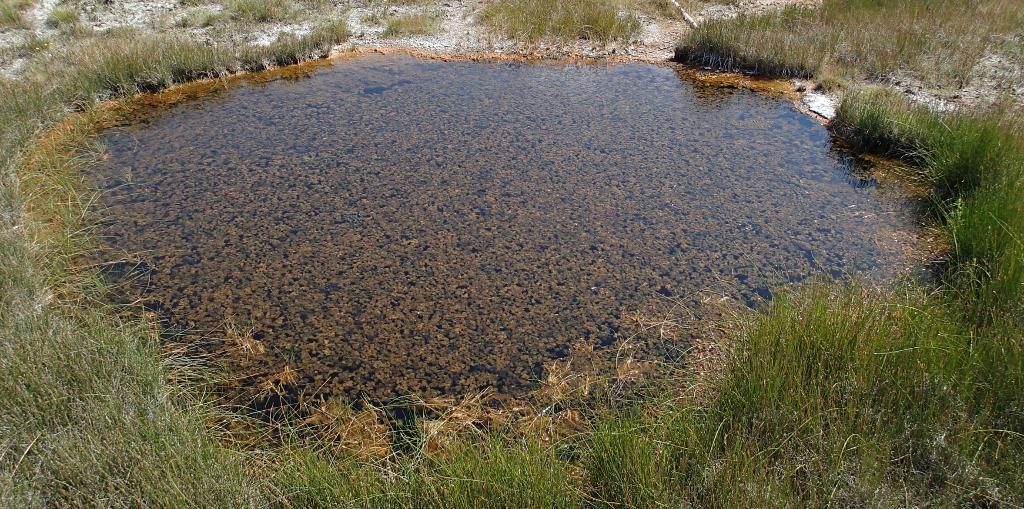Please provide a concise description of this image. In this image I can see water and green colour grass. 